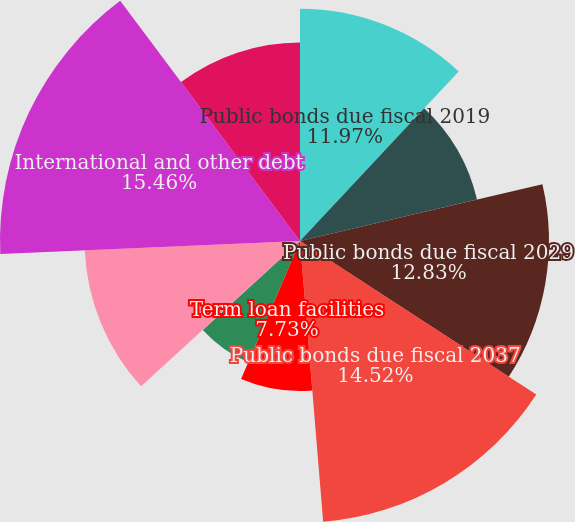Convert chart. <chart><loc_0><loc_0><loc_500><loc_500><pie_chart><fcel>Public bonds due fiscal 2019<fcel>Public bonds due fiscal 2023<fcel>Public bonds due fiscal 2029<fcel>Public bonds due fiscal 2037<fcel>Term loan facilities<fcel>Revolving credit and swing<fcel>Capital lease obligations<fcel>International and other debt<fcel>Total debt<nl><fcel>11.97%<fcel>9.37%<fcel>12.83%<fcel>14.52%<fcel>7.73%<fcel>6.79%<fcel>11.1%<fcel>15.46%<fcel>10.23%<nl></chart> 